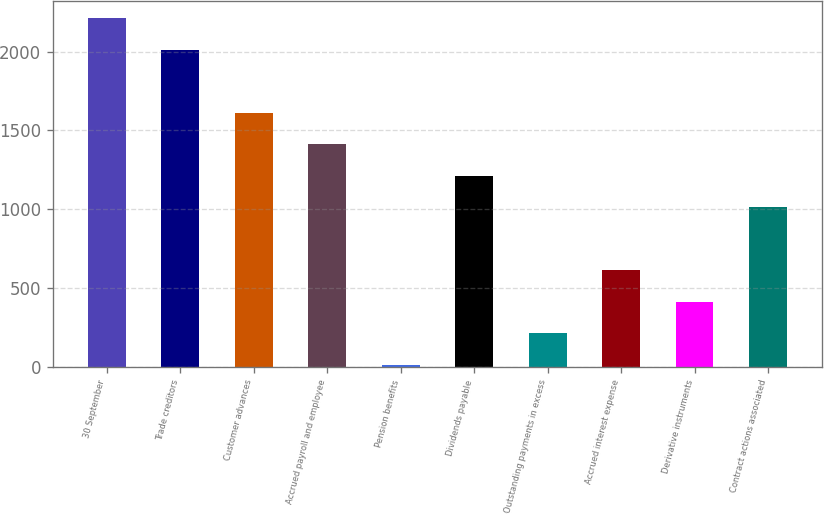<chart> <loc_0><loc_0><loc_500><loc_500><bar_chart><fcel>30 September<fcel>Trade creditors<fcel>Customer advances<fcel>Accrued payroll and employee<fcel>Pension benefits<fcel>Dividends payable<fcel>Outstanding payments in excess<fcel>Accrued interest expense<fcel>Derivative instruments<fcel>Contract actions associated<nl><fcel>2211.85<fcel>2012<fcel>1612.3<fcel>1412.45<fcel>13.5<fcel>1212.6<fcel>213.35<fcel>613.05<fcel>413.2<fcel>1012.75<nl></chart> 